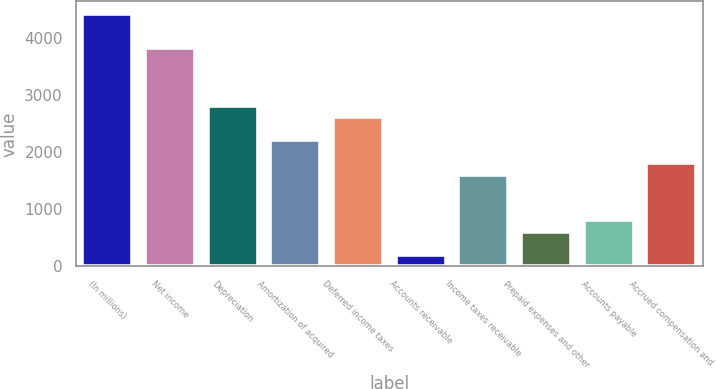Convert chart. <chart><loc_0><loc_0><loc_500><loc_500><bar_chart><fcel>(In millions)<fcel>Net income<fcel>Depreciation<fcel>Amortization of acquired<fcel>Deferred income taxes<fcel>Accounts receivable<fcel>Income taxes receivable<fcel>Prepaid expenses and other<fcel>Accounts payable<fcel>Accrued compensation and<nl><fcel>4429.6<fcel>3825.7<fcel>2819.2<fcel>2215.3<fcel>2617.9<fcel>202.3<fcel>1611.4<fcel>604.9<fcel>806.2<fcel>1812.7<nl></chart> 